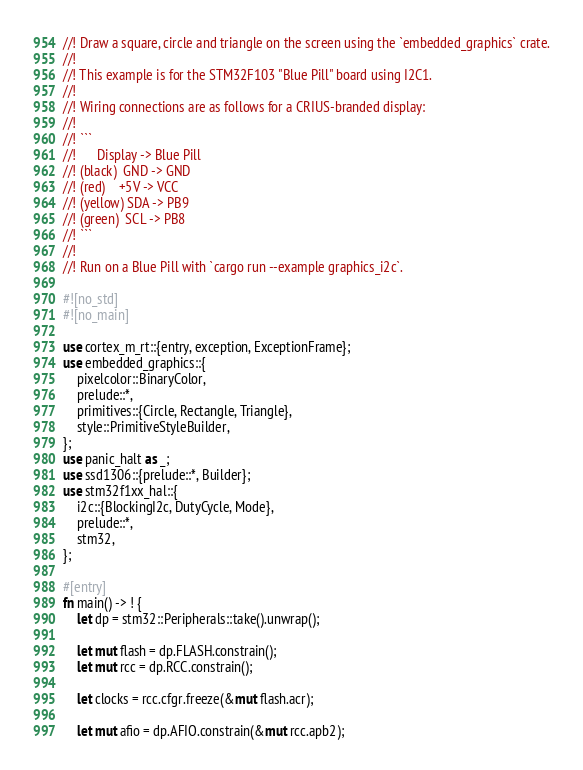Convert code to text. <code><loc_0><loc_0><loc_500><loc_500><_Rust_>//! Draw a square, circle and triangle on the screen using the `embedded_graphics` crate.
//!
//! This example is for the STM32F103 "Blue Pill" board using I2C1.
//!
//! Wiring connections are as follows for a CRIUS-branded display:
//!
//! ```
//!      Display -> Blue Pill
//! (black)  GND -> GND
//! (red)    +5V -> VCC
//! (yellow) SDA -> PB9
//! (green)  SCL -> PB8
//! ```
//!
//! Run on a Blue Pill with `cargo run --example graphics_i2c`.

#![no_std]
#![no_main]

use cortex_m_rt::{entry, exception, ExceptionFrame};
use embedded_graphics::{
    pixelcolor::BinaryColor,
    prelude::*,
    primitives::{Circle, Rectangle, Triangle},
    style::PrimitiveStyleBuilder,
};
use panic_halt as _;
use ssd1306::{prelude::*, Builder};
use stm32f1xx_hal::{
    i2c::{BlockingI2c, DutyCycle, Mode},
    prelude::*,
    stm32,
};

#[entry]
fn main() -> ! {
    let dp = stm32::Peripherals::take().unwrap();

    let mut flash = dp.FLASH.constrain();
    let mut rcc = dp.RCC.constrain();

    let clocks = rcc.cfgr.freeze(&mut flash.acr);

    let mut afio = dp.AFIO.constrain(&mut rcc.apb2);
</code> 